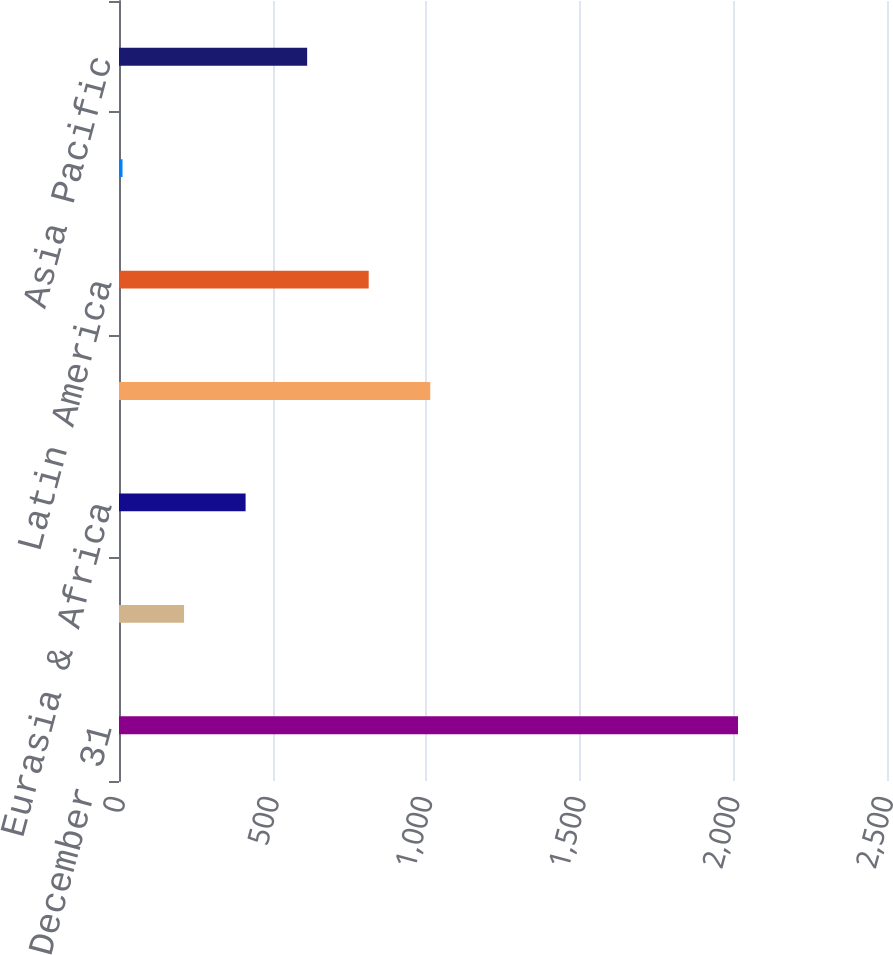Convert chart to OTSL. <chart><loc_0><loc_0><loc_500><loc_500><bar_chart><fcel>Year Ended December 31<fcel>Consolidated<fcel>Eurasia & Africa<fcel>Europe<fcel>Latin America<fcel>North America<fcel>Asia Pacific<nl><fcel>2015<fcel>211.76<fcel>412.12<fcel>1013.2<fcel>812.84<fcel>11.4<fcel>612.48<nl></chart> 